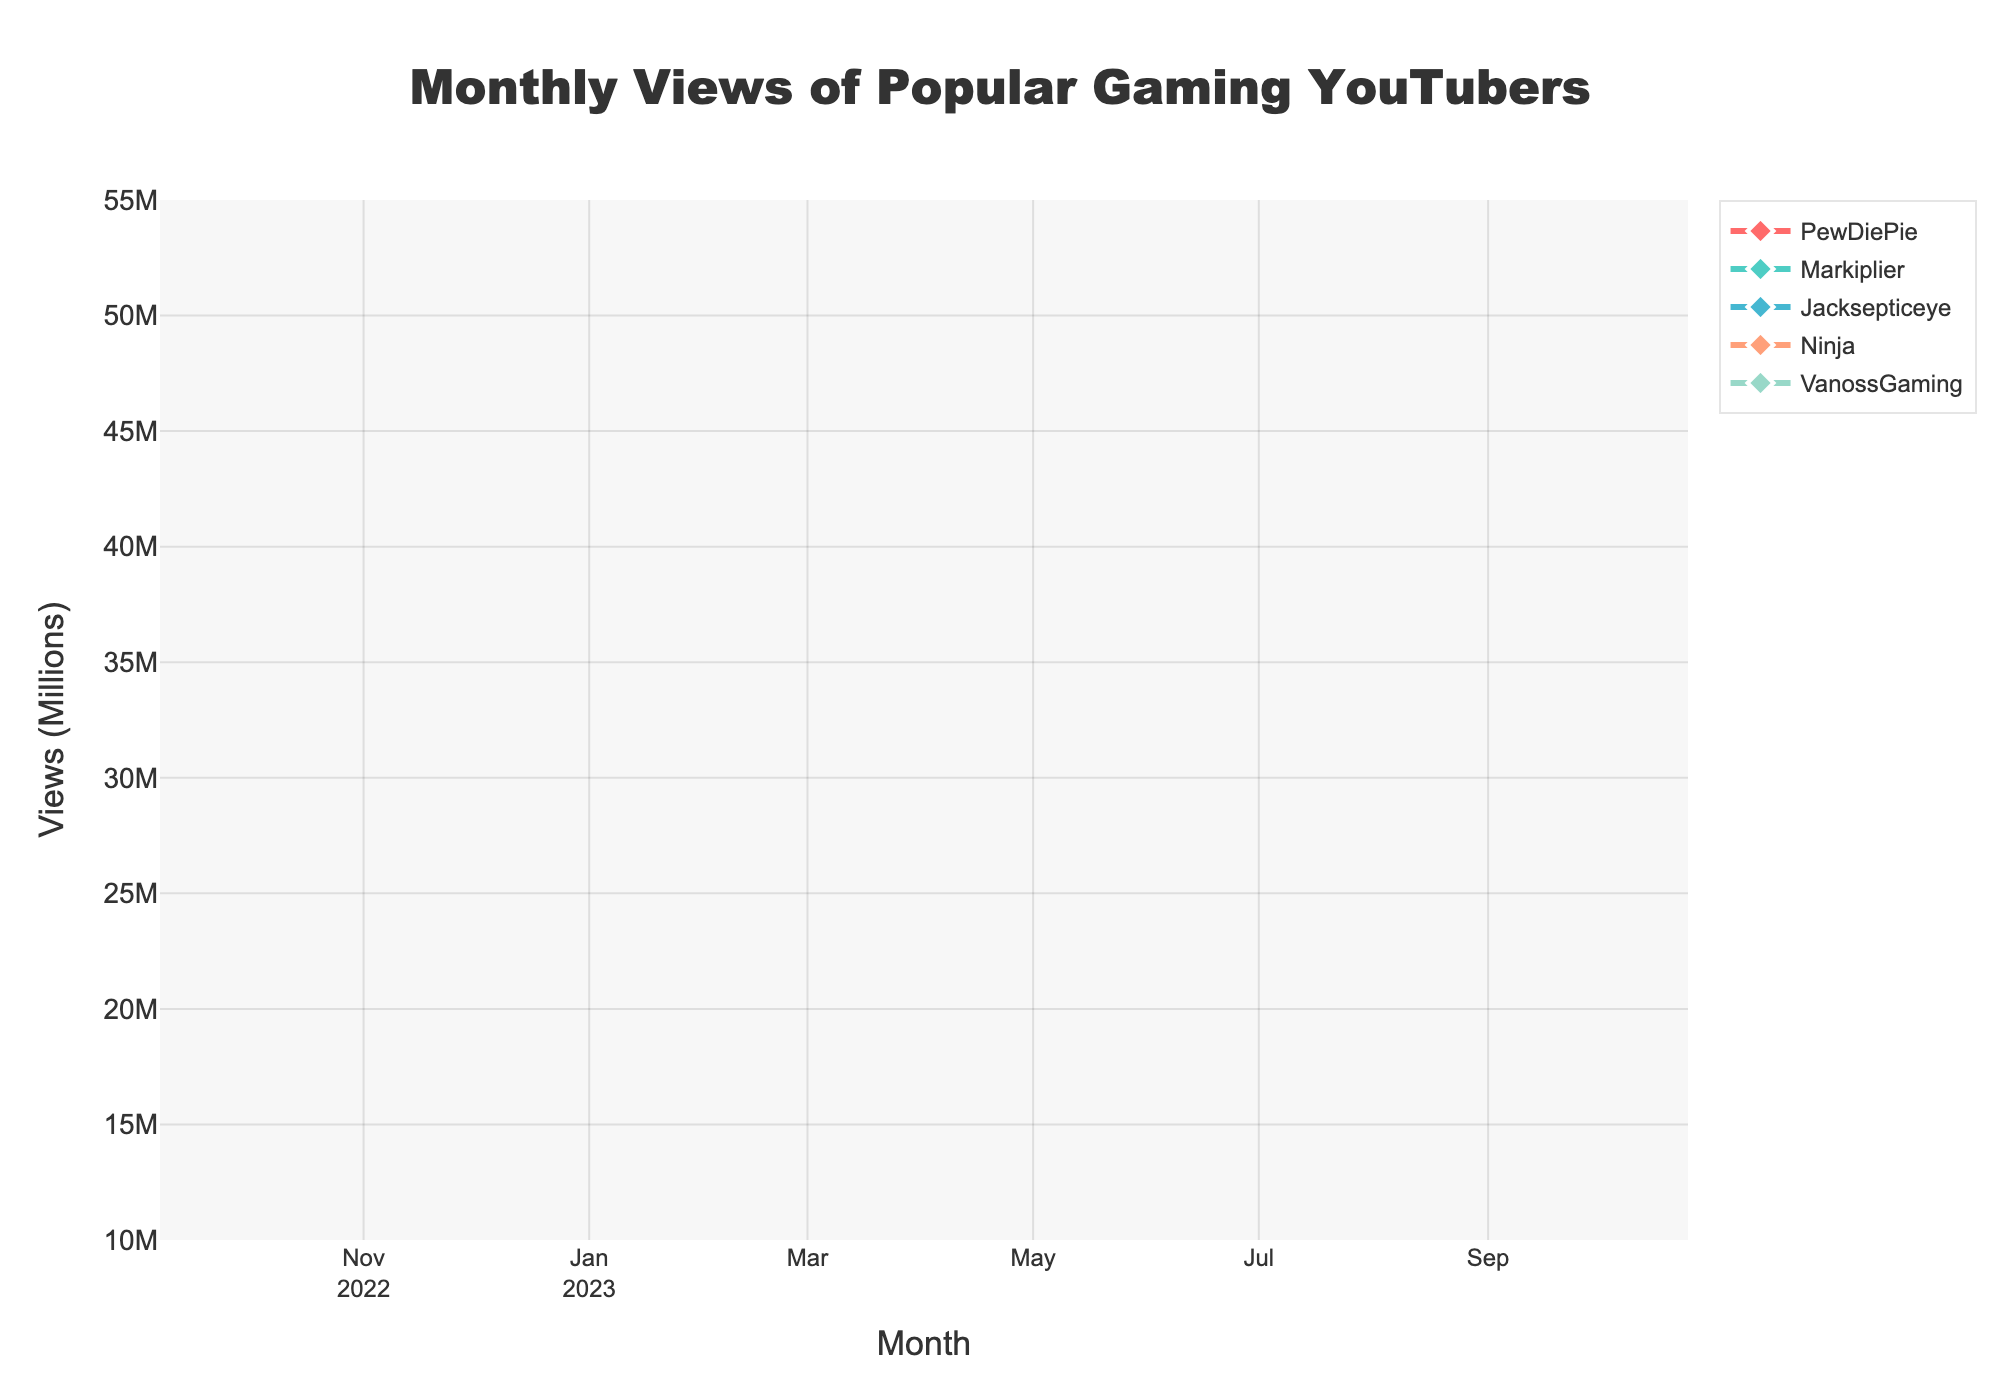What's the title of the plot? The title of the plot is located at the top center of the figure. It provides an overview of what the figure represents.
Answer: Monthly Views of Popular Gaming YouTubers Which YouTuber has the highest views in October 2023? To identify the YouTuber with the highest views, look at the marks on the plot for October 2023 and compare the heights. The highest mark corresponds to the highest views.
Answer: PewDiePie Which YouTuber had the most significant increase in views from February 2023 to March 2023? Compare the number of views for each YouTuber in February and March 2023. Calculate the difference and identify the YouTuber with the highest positive difference.
Answer: Jacksepticeye From the plot, during which month did Ninja's views surpass 20 million? Trace Ninja's views over the months and identify the first month where the marker goes above the 20 million mark on the y-axis.
Answer: July 2023 What's the average monthly views of VanossGaming over the year? Sum up the monthly views for VanossGaming from October 2022 to October 2023, then divide by the number of months (13) to get the average. (20000000 + 21000000 + 22000000 + 23000000 + 24000000 + 25000000 + 26000000 + 27000000 + 28000000 + 29000000 + 30000000 + 31000000 + 32000000) / 13
Answer: 25 million Who had the lowest views in December 2022? Look at the data points for each YouTuber in December 2022. The lowest point corresponds to the YouTuber with the lowest views.
Answer: Ninja How did PewDiePie's views change over the year? Observe the trend line for PewDiePie. Note the monthly changes and describe whether the views generally increased, decreased, or fluctuated.
Answer: Increased Compare the total views from January 2023 to June 2023 for Markiplier and Jacksepticeye. Who had more views? Sum the monthly views for January to June 2023 for Markiplier (25000000 + 26000000 + 27000000 + 28000000 + 29000000 + 30000000) and Jacksepticeye (28000000 + 29000000 + 30000000 + 31000000 + 32000000 + 33000000). Compare the totals.
Answer: Jacksepticeye Which YouTuber has the most consistent viewing trend over the year? Identify the YouTuber whose trend line shows the least fluctuation in views over the months.
Answer: PewDiePie During which month did Jacksepticeye's views reach 35 million? Locate the data point for Jacksepticeye that hits the 35 million mark on the y-axis and note the corresponding month from the x-axis.
Answer: August 2023 